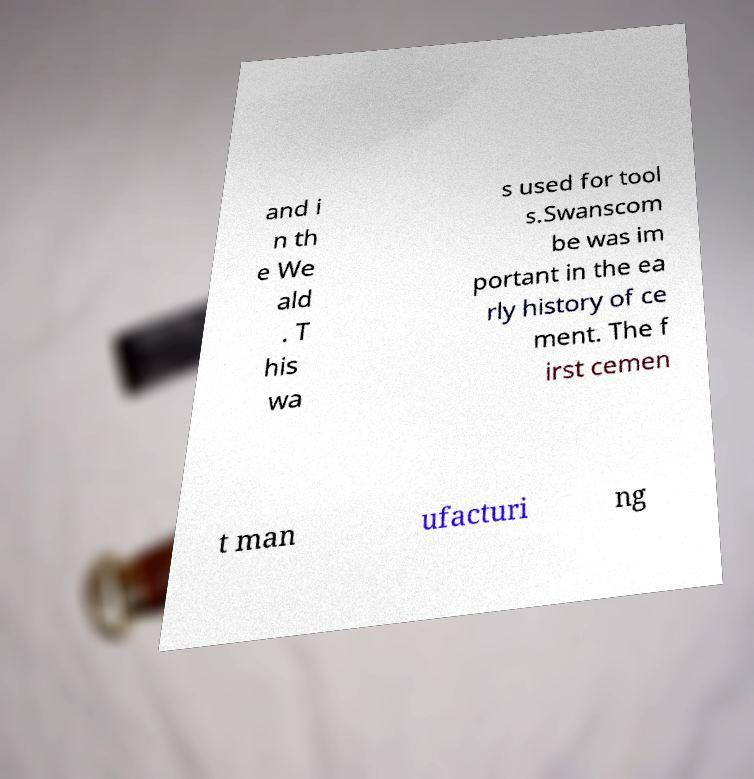For documentation purposes, I need the text within this image transcribed. Could you provide that? and i n th e We ald . T his wa s used for tool s.Swanscom be was im portant in the ea rly history of ce ment. The f irst cemen t man ufacturi ng 